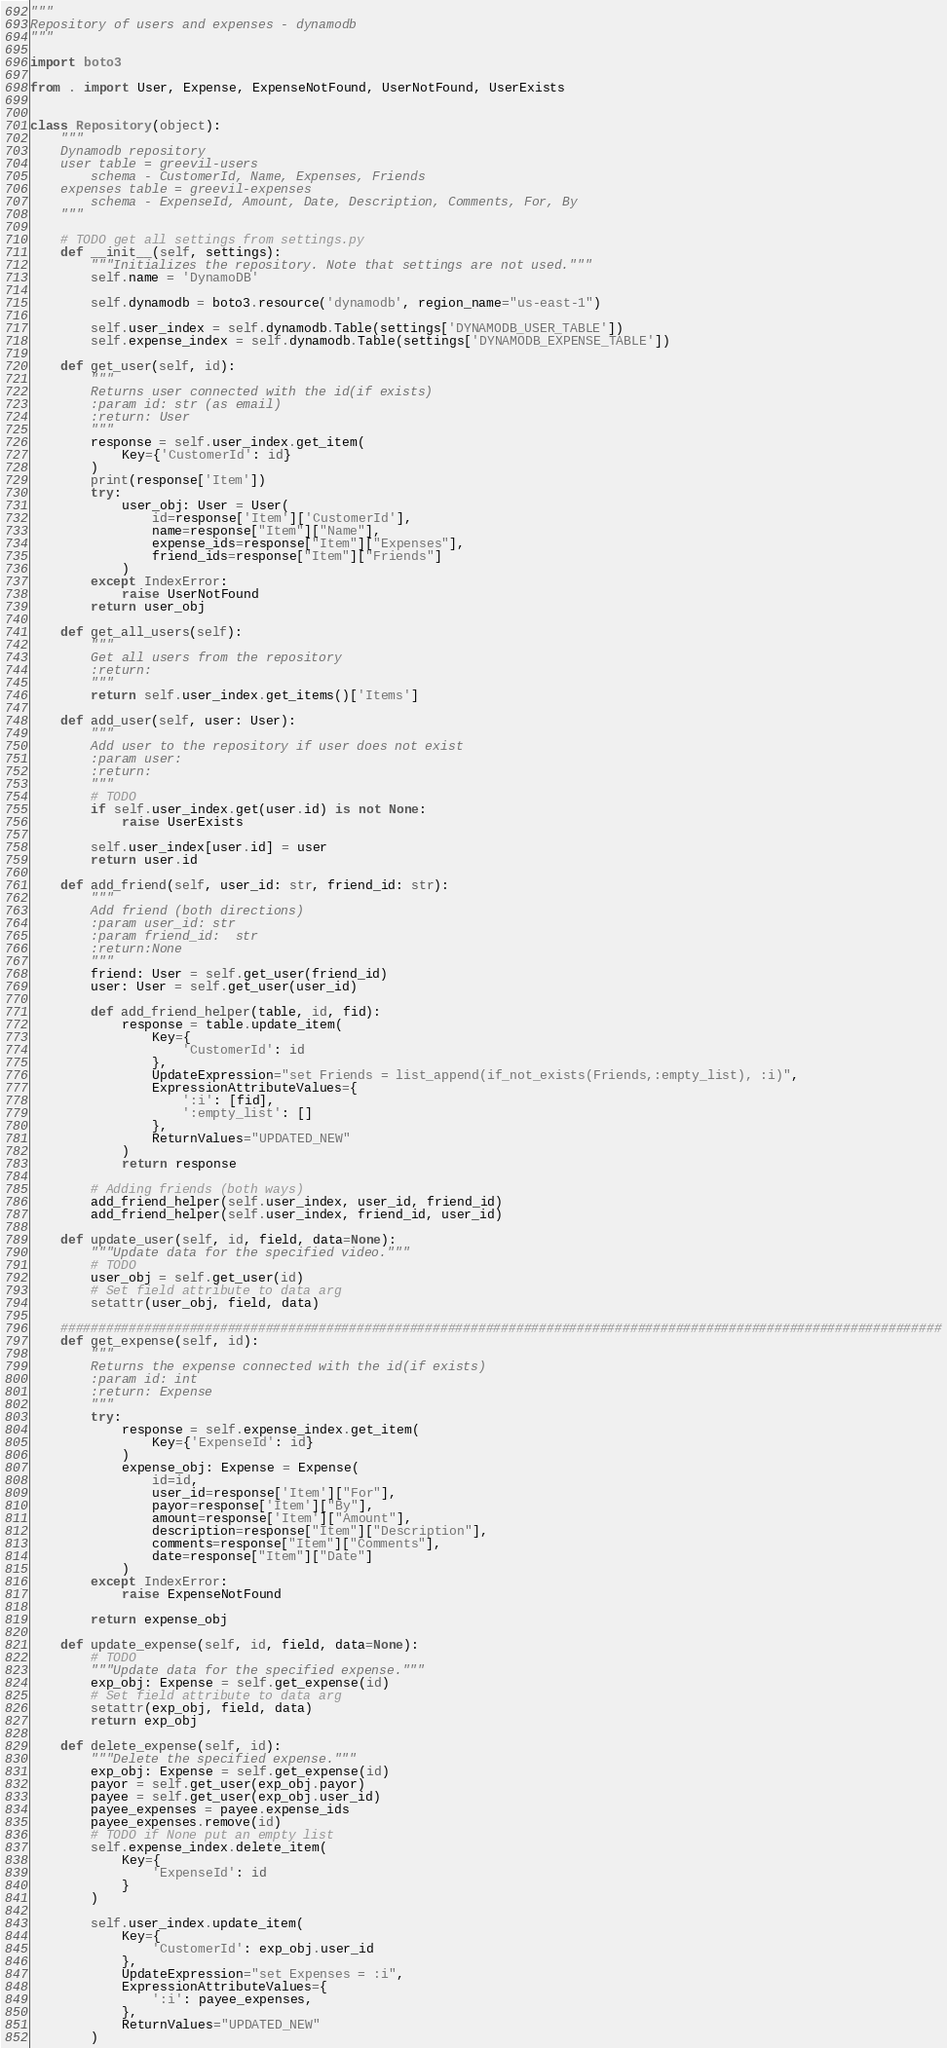Convert code to text. <code><loc_0><loc_0><loc_500><loc_500><_Python_>"""
Repository of users and expenses - dynamodb
"""

import boto3

from . import User, Expense, ExpenseNotFound, UserNotFound, UserExists


class Repository(object):
    """
    Dynamodb repository
    user table = greevil-users
        schema - CustomerId, Name, Expenses, Friends
    expenses table = greevil-expenses
        schema - ExpenseId, Amount, Date, Description, Comments, For, By
    """

    # TODO get all settings from settings.py
    def __init__(self, settings):
        """Initializes the repository. Note that settings are not used."""
        self.name = 'DynamoDB'

        self.dynamodb = boto3.resource('dynamodb', region_name="us-east-1")

        self.user_index = self.dynamodb.Table(settings['DYNAMODB_USER_TABLE'])
        self.expense_index = self.dynamodb.Table(settings['DYNAMODB_EXPENSE_TABLE'])

    def get_user(self, id):
        """
        Returns user connected with the id(if exists)
        :param id: str (as email)
        :return: User
        """
        response = self.user_index.get_item(
            Key={'CustomerId': id}
        )
        print(response['Item'])
        try:
            user_obj: User = User(
                id=response['Item']['CustomerId'],
                name=response["Item"]["Name"],
                expense_ids=response["Item"]["Expenses"],
                friend_ids=response["Item"]["Friends"]
            )
        except IndexError:
            raise UserNotFound
        return user_obj

    def get_all_users(self):
        """
        Get all users from the repository
        :return:
        """
        return self.user_index.get_items()['Items']

    def add_user(self, user: User):
        """
        Add user to the repository if user does not exist
        :param user:
        :return:
        """
        # TODO
        if self.user_index.get(user.id) is not None:
            raise UserExists

        self.user_index[user.id] = user
        return user.id

    def add_friend(self, user_id: str, friend_id: str):
        """
        Add friend (both directions)
        :param user_id: str
        :param friend_id:  str
        :return:None
        """
        friend: User = self.get_user(friend_id)
        user: User = self.get_user(user_id)

        def add_friend_helper(table, id, fid):
            response = table.update_item(
                Key={
                    'CustomerId': id
                },
                UpdateExpression="set Friends = list_append(if_not_exists(Friends,:empty_list), :i)",
                ExpressionAttributeValues={
                    ':i': [fid],
                    ':empty_list': []
                },
                ReturnValues="UPDATED_NEW"
            )
            return response

        # Adding friends (both ways)
        add_friend_helper(self.user_index, user_id, friend_id)
        add_friend_helper(self.user_index, friend_id, user_id)

    def update_user(self, id, field, data=None):
        """Update data for the specified video."""
        # TODO
        user_obj = self.get_user(id)
        # Set field attribute to data arg
        setattr(user_obj, field, data)

    ####################################################################################################################
    def get_expense(self, id):
        """
        Returns the expense connected with the id(if exists)
        :param id: int
        :return: Expense
        """
        try:
            response = self.expense_index.get_item(
                Key={'ExpenseId': id}
            )
            expense_obj: Expense = Expense(
                id=id,
                user_id=response['Item']["For"],
                payor=response['Item']["By"],
                amount=response['Item']["Amount"],
                description=response["Item"]["Description"],
                comments=response["Item"]["Comments"],
                date=response["Item"]["Date"]
            )
        except IndexError:
            raise ExpenseNotFound

        return expense_obj

    def update_expense(self, id, field, data=None):
        # TODO
        """Update data for the specified expense."""
        exp_obj: Expense = self.get_expense(id)
        # Set field attribute to data arg
        setattr(exp_obj, field, data)
        return exp_obj

    def delete_expense(self, id):
        """Delete the specified expense."""
        exp_obj: Expense = self.get_expense(id)
        payor = self.get_user(exp_obj.payor)
        payee = self.get_user(exp_obj.user_id)
        payee_expenses = payee.expense_ids
        payee_expenses.remove(id)
        # TODO if None put an empty list
        self.expense_index.delete_item(
            Key={
                'ExpenseId': id
            }
        )

        self.user_index.update_item(
            Key={
                'CustomerId': exp_obj.user_id
            },
            UpdateExpression="set Expenses = :i",
            ExpressionAttributeValues={
                ':i': payee_expenses,
            },
            ReturnValues="UPDATED_NEW"
        )
</code> 